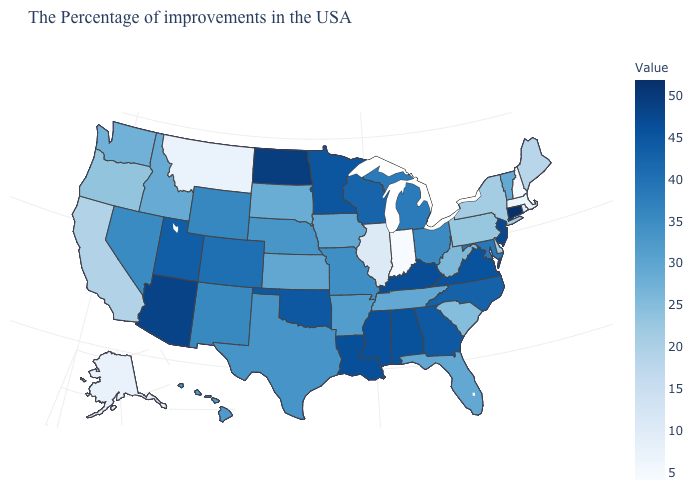Which states hav the highest value in the MidWest?
Keep it brief. North Dakota. Among the states that border Arizona , does Utah have the highest value?
Give a very brief answer. Yes. Does New York have a lower value than New Hampshire?
Be succinct. No. 